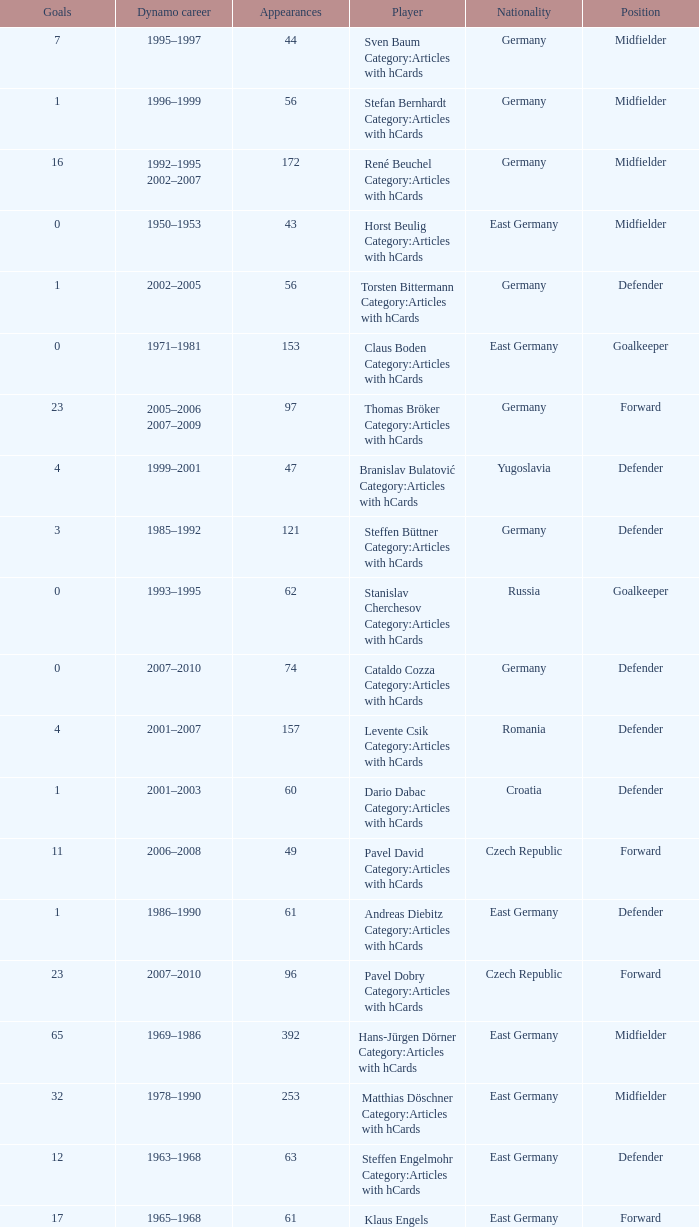What was the position of the player with 57 goals? Forward. 